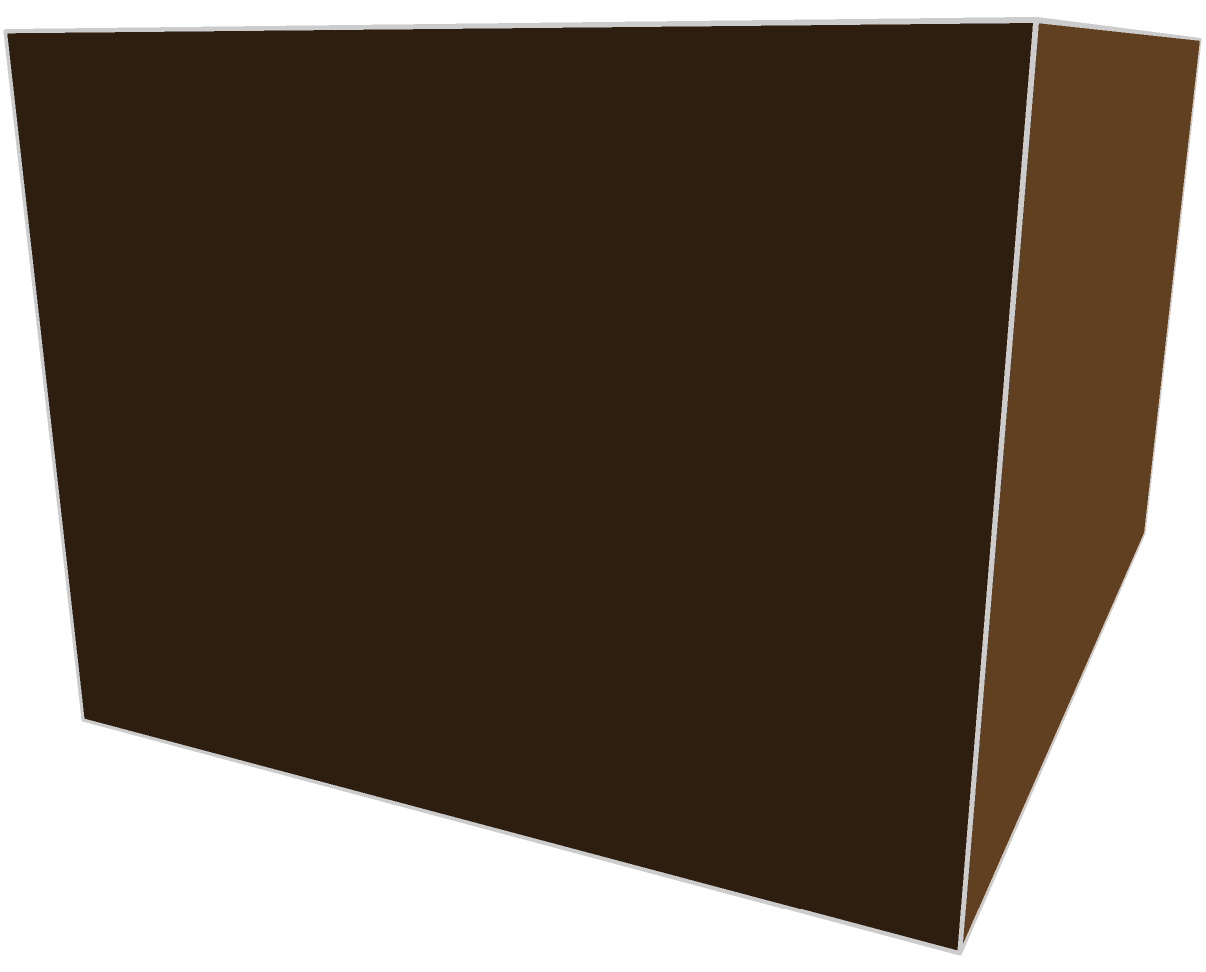As a Sassparilla enthusiast, you're tasked with organizing the storage of your favorite beverage. Given a storage space measuring 5 units long, 4 units wide, and 3 units high, and assuming each Sassparilla crate is a perfect cube with 1 unit dimensions, what is the maximum number of Sassparilla crates that can be stored in this space? To determine the maximum number of Sassparilla crates that can be stored in the given space, we need to follow these steps:

1. Identify the dimensions of the storage space:
   Length (L) = 5 units
   Width (W) = 4 units
   Height (H) = 3 units

2. Identify the dimensions of each Sassparilla crate:
   Each crate is a cube with 1 unit dimensions (1x1x1)

3. Calculate the number of crates that can fit in each dimension:
   Length: 5 ÷ 1 = 5 crates
   Width: 4 ÷ 1 = 4 crates
   Height: 3 ÷ 1 = 3 crates

4. Calculate the total number of crates:
   Total crates = Length × Width × Height
   Total crates = 5 × 4 × 3 = 60

Therefore, the maximum number of Sassparilla crates that can be stored in the given space is 60.
Answer: 60 crates 